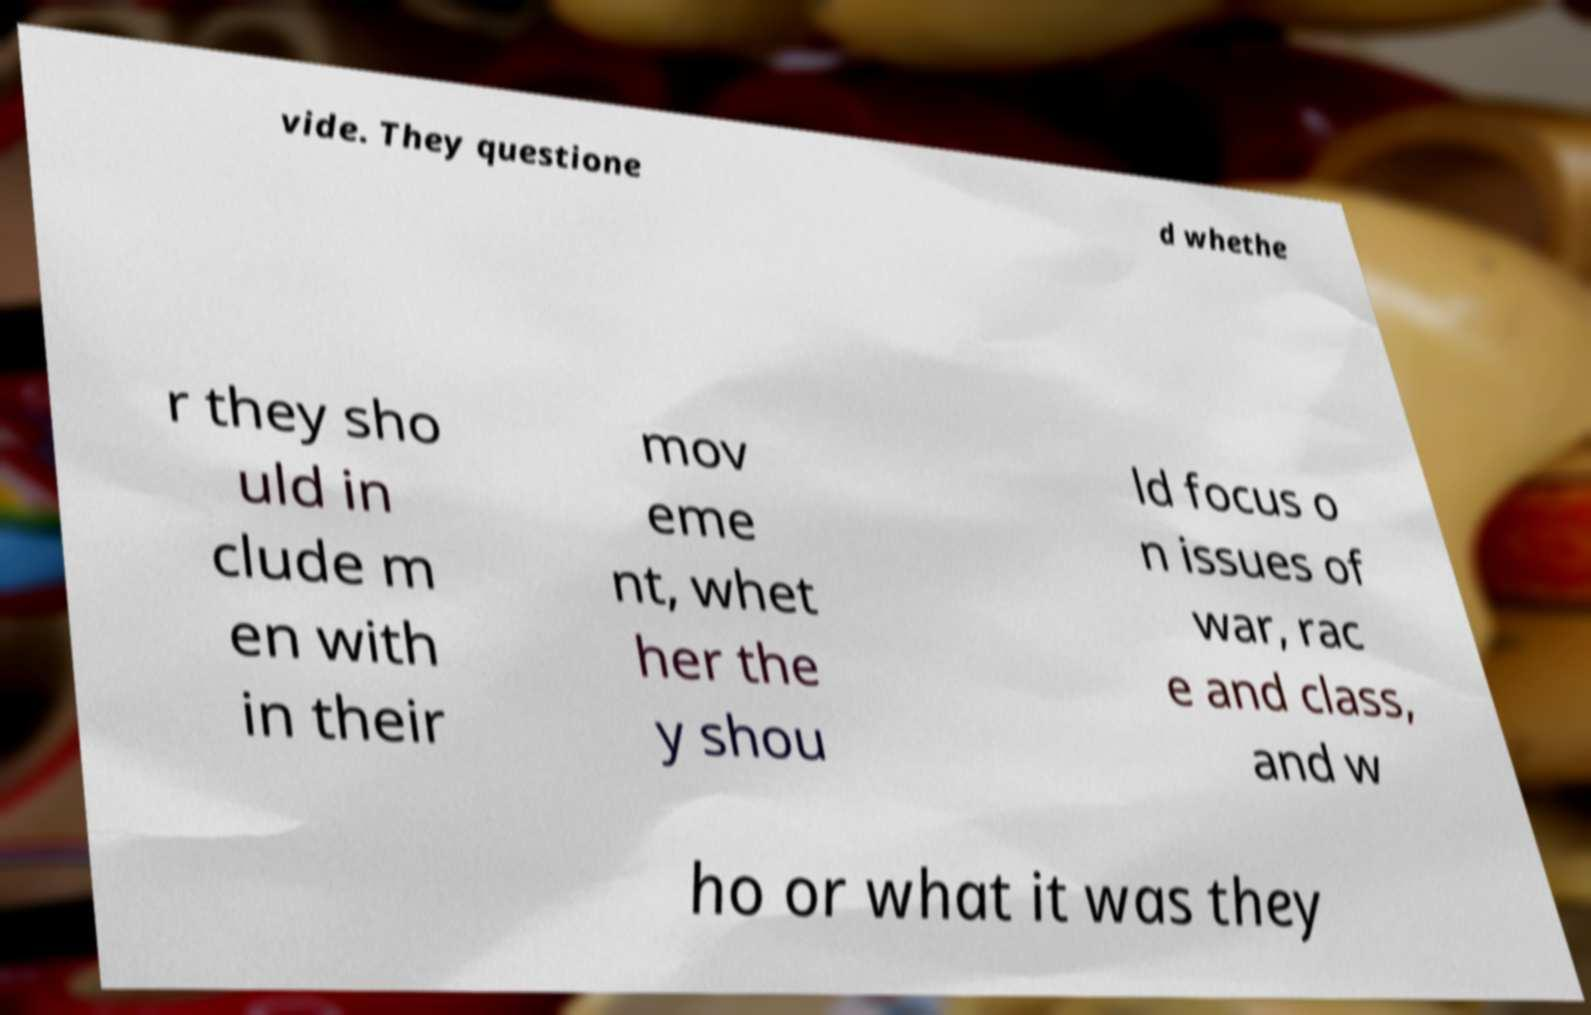Can you read and provide the text displayed in the image?This photo seems to have some interesting text. Can you extract and type it out for me? vide. They questione d whethe r they sho uld in clude m en with in their mov eme nt, whet her the y shou ld focus o n issues of war, rac e and class, and w ho or what it was they 